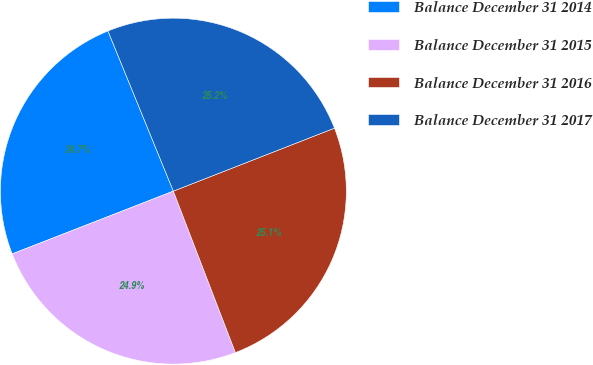Convert chart to OTSL. <chart><loc_0><loc_0><loc_500><loc_500><pie_chart><fcel>Balance December 31 2014<fcel>Balance December 31 2015<fcel>Balance December 31 2016<fcel>Balance December 31 2017<nl><fcel>24.74%<fcel>24.93%<fcel>25.09%<fcel>25.24%<nl></chart> 